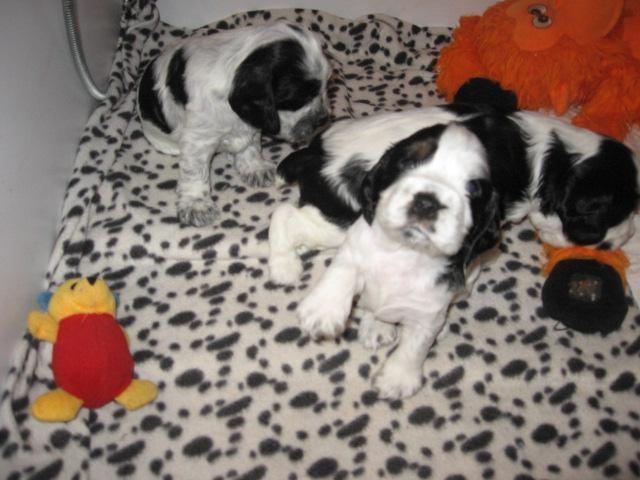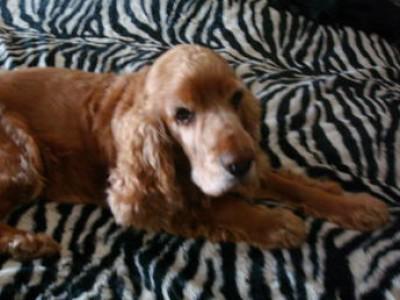The first image is the image on the left, the second image is the image on the right. For the images displayed, is the sentence "A litter of puppies is being fed by their mother." factually correct? Answer yes or no. No. The first image is the image on the left, the second image is the image on the right. For the images displayed, is the sentence "The right image contains no more than one dog." factually correct? Answer yes or no. Yes. 